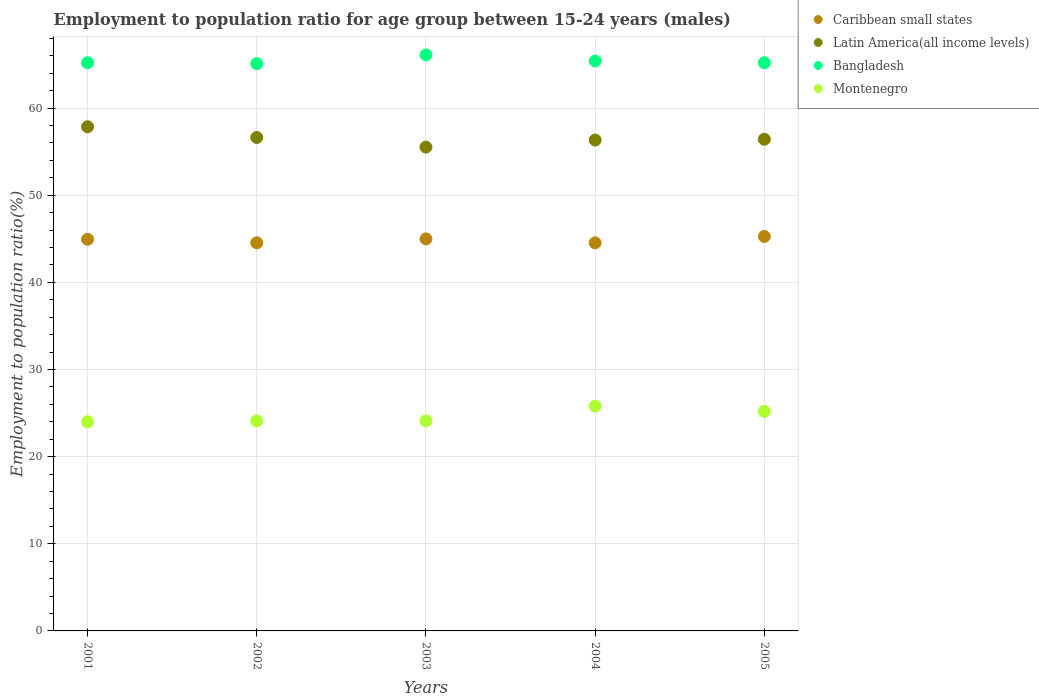What is the employment to population ratio in Bangladesh in 2001?
Offer a very short reply. 65.2. Across all years, what is the maximum employment to population ratio in Caribbean small states?
Keep it short and to the point. 45.27. Across all years, what is the minimum employment to population ratio in Latin America(all income levels)?
Your response must be concise. 55.52. In which year was the employment to population ratio in Latin America(all income levels) minimum?
Ensure brevity in your answer.  2003. What is the total employment to population ratio in Caribbean small states in the graph?
Keep it short and to the point. 224.27. What is the difference between the employment to population ratio in Montenegro in 2003 and that in 2004?
Provide a short and direct response. -1.7. What is the difference between the employment to population ratio in Montenegro in 2001 and the employment to population ratio in Caribbean small states in 2005?
Give a very brief answer. -21.27. What is the average employment to population ratio in Bangladesh per year?
Your answer should be compact. 65.4. In the year 2002, what is the difference between the employment to population ratio in Latin America(all income levels) and employment to population ratio in Bangladesh?
Offer a very short reply. -8.48. What is the ratio of the employment to population ratio in Latin America(all income levels) in 2003 to that in 2004?
Offer a very short reply. 0.99. What is the difference between the highest and the second highest employment to population ratio in Bangladesh?
Make the answer very short. 0.7. What is the difference between the highest and the lowest employment to population ratio in Caribbean small states?
Give a very brief answer. 0.73. Is the sum of the employment to population ratio in Montenegro in 2003 and 2005 greater than the maximum employment to population ratio in Bangladesh across all years?
Ensure brevity in your answer.  No. Is it the case that in every year, the sum of the employment to population ratio in Montenegro and employment to population ratio in Latin America(all income levels)  is greater than the employment to population ratio in Caribbean small states?
Your answer should be very brief. Yes. Is the employment to population ratio in Montenegro strictly greater than the employment to population ratio in Caribbean small states over the years?
Provide a succinct answer. No. Are the values on the major ticks of Y-axis written in scientific E-notation?
Offer a very short reply. No. Does the graph contain any zero values?
Offer a very short reply. No. Does the graph contain grids?
Your answer should be very brief. Yes. How are the legend labels stacked?
Give a very brief answer. Vertical. What is the title of the graph?
Offer a terse response. Employment to population ratio for age group between 15-24 years (males). Does "Aruba" appear as one of the legend labels in the graph?
Ensure brevity in your answer.  No. What is the Employment to population ratio(%) in Caribbean small states in 2001?
Make the answer very short. 44.94. What is the Employment to population ratio(%) of Latin America(all income levels) in 2001?
Provide a succinct answer. 57.85. What is the Employment to population ratio(%) of Bangladesh in 2001?
Make the answer very short. 65.2. What is the Employment to population ratio(%) of Montenegro in 2001?
Ensure brevity in your answer.  24. What is the Employment to population ratio(%) of Caribbean small states in 2002?
Give a very brief answer. 44.53. What is the Employment to population ratio(%) in Latin America(all income levels) in 2002?
Give a very brief answer. 56.62. What is the Employment to population ratio(%) of Bangladesh in 2002?
Provide a succinct answer. 65.1. What is the Employment to population ratio(%) of Montenegro in 2002?
Your answer should be compact. 24.1. What is the Employment to population ratio(%) in Caribbean small states in 2003?
Make the answer very short. 44.99. What is the Employment to population ratio(%) of Latin America(all income levels) in 2003?
Offer a terse response. 55.52. What is the Employment to population ratio(%) of Bangladesh in 2003?
Provide a short and direct response. 66.1. What is the Employment to population ratio(%) of Montenegro in 2003?
Make the answer very short. 24.1. What is the Employment to population ratio(%) in Caribbean small states in 2004?
Offer a very short reply. 44.54. What is the Employment to population ratio(%) of Latin America(all income levels) in 2004?
Your answer should be very brief. 56.33. What is the Employment to population ratio(%) of Bangladesh in 2004?
Your response must be concise. 65.4. What is the Employment to population ratio(%) in Montenegro in 2004?
Give a very brief answer. 25.8. What is the Employment to population ratio(%) of Caribbean small states in 2005?
Your answer should be very brief. 45.27. What is the Employment to population ratio(%) in Latin America(all income levels) in 2005?
Your answer should be compact. 56.42. What is the Employment to population ratio(%) of Bangladesh in 2005?
Your answer should be compact. 65.2. What is the Employment to population ratio(%) in Montenegro in 2005?
Your answer should be compact. 25.2. Across all years, what is the maximum Employment to population ratio(%) in Caribbean small states?
Ensure brevity in your answer.  45.27. Across all years, what is the maximum Employment to population ratio(%) in Latin America(all income levels)?
Your answer should be very brief. 57.85. Across all years, what is the maximum Employment to population ratio(%) of Bangladesh?
Give a very brief answer. 66.1. Across all years, what is the maximum Employment to population ratio(%) of Montenegro?
Your answer should be very brief. 25.8. Across all years, what is the minimum Employment to population ratio(%) of Caribbean small states?
Your answer should be compact. 44.53. Across all years, what is the minimum Employment to population ratio(%) of Latin America(all income levels)?
Your answer should be compact. 55.52. Across all years, what is the minimum Employment to population ratio(%) of Bangladesh?
Your answer should be very brief. 65.1. What is the total Employment to population ratio(%) in Caribbean small states in the graph?
Ensure brevity in your answer.  224.27. What is the total Employment to population ratio(%) of Latin America(all income levels) in the graph?
Keep it short and to the point. 282.75. What is the total Employment to population ratio(%) in Bangladesh in the graph?
Ensure brevity in your answer.  327. What is the total Employment to population ratio(%) in Montenegro in the graph?
Make the answer very short. 123.2. What is the difference between the Employment to population ratio(%) of Caribbean small states in 2001 and that in 2002?
Your response must be concise. 0.41. What is the difference between the Employment to population ratio(%) of Latin America(all income levels) in 2001 and that in 2002?
Make the answer very short. 1.23. What is the difference between the Employment to population ratio(%) of Caribbean small states in 2001 and that in 2003?
Offer a very short reply. -0.05. What is the difference between the Employment to population ratio(%) of Latin America(all income levels) in 2001 and that in 2003?
Offer a terse response. 2.33. What is the difference between the Employment to population ratio(%) of Montenegro in 2001 and that in 2003?
Give a very brief answer. -0.1. What is the difference between the Employment to population ratio(%) in Caribbean small states in 2001 and that in 2004?
Offer a very short reply. 0.41. What is the difference between the Employment to population ratio(%) in Latin America(all income levels) in 2001 and that in 2004?
Your response must be concise. 1.52. What is the difference between the Employment to population ratio(%) of Bangladesh in 2001 and that in 2004?
Give a very brief answer. -0.2. What is the difference between the Employment to population ratio(%) in Montenegro in 2001 and that in 2004?
Ensure brevity in your answer.  -1.8. What is the difference between the Employment to population ratio(%) of Caribbean small states in 2001 and that in 2005?
Provide a succinct answer. -0.32. What is the difference between the Employment to population ratio(%) in Latin America(all income levels) in 2001 and that in 2005?
Keep it short and to the point. 1.43. What is the difference between the Employment to population ratio(%) in Montenegro in 2001 and that in 2005?
Provide a short and direct response. -1.2. What is the difference between the Employment to population ratio(%) of Caribbean small states in 2002 and that in 2003?
Give a very brief answer. -0.46. What is the difference between the Employment to population ratio(%) in Latin America(all income levels) in 2002 and that in 2003?
Your answer should be very brief. 1.1. What is the difference between the Employment to population ratio(%) of Bangladesh in 2002 and that in 2003?
Offer a very short reply. -1. What is the difference between the Employment to population ratio(%) of Montenegro in 2002 and that in 2003?
Provide a short and direct response. 0. What is the difference between the Employment to population ratio(%) in Caribbean small states in 2002 and that in 2004?
Your answer should be compact. -0. What is the difference between the Employment to population ratio(%) in Latin America(all income levels) in 2002 and that in 2004?
Your response must be concise. 0.29. What is the difference between the Employment to population ratio(%) of Caribbean small states in 2002 and that in 2005?
Give a very brief answer. -0.73. What is the difference between the Employment to population ratio(%) in Latin America(all income levels) in 2002 and that in 2005?
Give a very brief answer. 0.2. What is the difference between the Employment to population ratio(%) in Caribbean small states in 2003 and that in 2004?
Offer a very short reply. 0.45. What is the difference between the Employment to population ratio(%) in Latin America(all income levels) in 2003 and that in 2004?
Give a very brief answer. -0.81. What is the difference between the Employment to population ratio(%) of Bangladesh in 2003 and that in 2004?
Your response must be concise. 0.7. What is the difference between the Employment to population ratio(%) in Caribbean small states in 2003 and that in 2005?
Your response must be concise. -0.28. What is the difference between the Employment to population ratio(%) of Latin America(all income levels) in 2003 and that in 2005?
Keep it short and to the point. -0.9. What is the difference between the Employment to population ratio(%) of Montenegro in 2003 and that in 2005?
Provide a short and direct response. -1.1. What is the difference between the Employment to population ratio(%) in Caribbean small states in 2004 and that in 2005?
Provide a succinct answer. -0.73. What is the difference between the Employment to population ratio(%) of Latin America(all income levels) in 2004 and that in 2005?
Your answer should be very brief. -0.09. What is the difference between the Employment to population ratio(%) of Caribbean small states in 2001 and the Employment to population ratio(%) of Latin America(all income levels) in 2002?
Your response must be concise. -11.68. What is the difference between the Employment to population ratio(%) of Caribbean small states in 2001 and the Employment to population ratio(%) of Bangladesh in 2002?
Ensure brevity in your answer.  -20.16. What is the difference between the Employment to population ratio(%) of Caribbean small states in 2001 and the Employment to population ratio(%) of Montenegro in 2002?
Offer a very short reply. 20.84. What is the difference between the Employment to population ratio(%) of Latin America(all income levels) in 2001 and the Employment to population ratio(%) of Bangladesh in 2002?
Your answer should be very brief. -7.25. What is the difference between the Employment to population ratio(%) in Latin America(all income levels) in 2001 and the Employment to population ratio(%) in Montenegro in 2002?
Provide a short and direct response. 33.75. What is the difference between the Employment to population ratio(%) in Bangladesh in 2001 and the Employment to population ratio(%) in Montenegro in 2002?
Give a very brief answer. 41.1. What is the difference between the Employment to population ratio(%) of Caribbean small states in 2001 and the Employment to population ratio(%) of Latin America(all income levels) in 2003?
Ensure brevity in your answer.  -10.58. What is the difference between the Employment to population ratio(%) in Caribbean small states in 2001 and the Employment to population ratio(%) in Bangladesh in 2003?
Give a very brief answer. -21.16. What is the difference between the Employment to population ratio(%) in Caribbean small states in 2001 and the Employment to population ratio(%) in Montenegro in 2003?
Make the answer very short. 20.84. What is the difference between the Employment to population ratio(%) of Latin America(all income levels) in 2001 and the Employment to population ratio(%) of Bangladesh in 2003?
Your answer should be very brief. -8.25. What is the difference between the Employment to population ratio(%) in Latin America(all income levels) in 2001 and the Employment to population ratio(%) in Montenegro in 2003?
Ensure brevity in your answer.  33.75. What is the difference between the Employment to population ratio(%) in Bangladesh in 2001 and the Employment to population ratio(%) in Montenegro in 2003?
Offer a very short reply. 41.1. What is the difference between the Employment to population ratio(%) in Caribbean small states in 2001 and the Employment to population ratio(%) in Latin America(all income levels) in 2004?
Keep it short and to the point. -11.39. What is the difference between the Employment to population ratio(%) of Caribbean small states in 2001 and the Employment to population ratio(%) of Bangladesh in 2004?
Make the answer very short. -20.46. What is the difference between the Employment to population ratio(%) in Caribbean small states in 2001 and the Employment to population ratio(%) in Montenegro in 2004?
Offer a very short reply. 19.14. What is the difference between the Employment to population ratio(%) of Latin America(all income levels) in 2001 and the Employment to population ratio(%) of Bangladesh in 2004?
Your answer should be very brief. -7.55. What is the difference between the Employment to population ratio(%) in Latin America(all income levels) in 2001 and the Employment to population ratio(%) in Montenegro in 2004?
Provide a short and direct response. 32.05. What is the difference between the Employment to population ratio(%) in Bangladesh in 2001 and the Employment to population ratio(%) in Montenegro in 2004?
Provide a short and direct response. 39.4. What is the difference between the Employment to population ratio(%) of Caribbean small states in 2001 and the Employment to population ratio(%) of Latin America(all income levels) in 2005?
Your answer should be compact. -11.48. What is the difference between the Employment to population ratio(%) in Caribbean small states in 2001 and the Employment to population ratio(%) in Bangladesh in 2005?
Provide a succinct answer. -20.26. What is the difference between the Employment to population ratio(%) in Caribbean small states in 2001 and the Employment to population ratio(%) in Montenegro in 2005?
Your answer should be very brief. 19.74. What is the difference between the Employment to population ratio(%) of Latin America(all income levels) in 2001 and the Employment to population ratio(%) of Bangladesh in 2005?
Keep it short and to the point. -7.35. What is the difference between the Employment to population ratio(%) of Latin America(all income levels) in 2001 and the Employment to population ratio(%) of Montenegro in 2005?
Give a very brief answer. 32.65. What is the difference between the Employment to population ratio(%) of Bangladesh in 2001 and the Employment to population ratio(%) of Montenegro in 2005?
Ensure brevity in your answer.  40. What is the difference between the Employment to population ratio(%) of Caribbean small states in 2002 and the Employment to population ratio(%) of Latin America(all income levels) in 2003?
Give a very brief answer. -10.99. What is the difference between the Employment to population ratio(%) of Caribbean small states in 2002 and the Employment to population ratio(%) of Bangladesh in 2003?
Provide a succinct answer. -21.57. What is the difference between the Employment to population ratio(%) in Caribbean small states in 2002 and the Employment to population ratio(%) in Montenegro in 2003?
Your answer should be very brief. 20.43. What is the difference between the Employment to population ratio(%) in Latin America(all income levels) in 2002 and the Employment to population ratio(%) in Bangladesh in 2003?
Make the answer very short. -9.48. What is the difference between the Employment to population ratio(%) of Latin America(all income levels) in 2002 and the Employment to population ratio(%) of Montenegro in 2003?
Make the answer very short. 32.52. What is the difference between the Employment to population ratio(%) of Bangladesh in 2002 and the Employment to population ratio(%) of Montenegro in 2003?
Offer a very short reply. 41. What is the difference between the Employment to population ratio(%) of Caribbean small states in 2002 and the Employment to population ratio(%) of Latin America(all income levels) in 2004?
Offer a terse response. -11.8. What is the difference between the Employment to population ratio(%) of Caribbean small states in 2002 and the Employment to population ratio(%) of Bangladesh in 2004?
Keep it short and to the point. -20.87. What is the difference between the Employment to population ratio(%) of Caribbean small states in 2002 and the Employment to population ratio(%) of Montenegro in 2004?
Your answer should be compact. 18.73. What is the difference between the Employment to population ratio(%) in Latin America(all income levels) in 2002 and the Employment to population ratio(%) in Bangladesh in 2004?
Provide a short and direct response. -8.78. What is the difference between the Employment to population ratio(%) in Latin America(all income levels) in 2002 and the Employment to population ratio(%) in Montenegro in 2004?
Offer a terse response. 30.82. What is the difference between the Employment to population ratio(%) in Bangladesh in 2002 and the Employment to population ratio(%) in Montenegro in 2004?
Offer a very short reply. 39.3. What is the difference between the Employment to population ratio(%) in Caribbean small states in 2002 and the Employment to population ratio(%) in Latin America(all income levels) in 2005?
Offer a terse response. -11.89. What is the difference between the Employment to population ratio(%) in Caribbean small states in 2002 and the Employment to population ratio(%) in Bangladesh in 2005?
Offer a very short reply. -20.67. What is the difference between the Employment to population ratio(%) in Caribbean small states in 2002 and the Employment to population ratio(%) in Montenegro in 2005?
Offer a terse response. 19.33. What is the difference between the Employment to population ratio(%) of Latin America(all income levels) in 2002 and the Employment to population ratio(%) of Bangladesh in 2005?
Your response must be concise. -8.58. What is the difference between the Employment to population ratio(%) of Latin America(all income levels) in 2002 and the Employment to population ratio(%) of Montenegro in 2005?
Provide a succinct answer. 31.42. What is the difference between the Employment to population ratio(%) in Bangladesh in 2002 and the Employment to population ratio(%) in Montenegro in 2005?
Give a very brief answer. 39.9. What is the difference between the Employment to population ratio(%) in Caribbean small states in 2003 and the Employment to population ratio(%) in Latin America(all income levels) in 2004?
Provide a short and direct response. -11.34. What is the difference between the Employment to population ratio(%) of Caribbean small states in 2003 and the Employment to population ratio(%) of Bangladesh in 2004?
Provide a short and direct response. -20.41. What is the difference between the Employment to population ratio(%) in Caribbean small states in 2003 and the Employment to population ratio(%) in Montenegro in 2004?
Ensure brevity in your answer.  19.19. What is the difference between the Employment to population ratio(%) in Latin America(all income levels) in 2003 and the Employment to population ratio(%) in Bangladesh in 2004?
Keep it short and to the point. -9.88. What is the difference between the Employment to population ratio(%) of Latin America(all income levels) in 2003 and the Employment to population ratio(%) of Montenegro in 2004?
Your response must be concise. 29.72. What is the difference between the Employment to population ratio(%) in Bangladesh in 2003 and the Employment to population ratio(%) in Montenegro in 2004?
Provide a short and direct response. 40.3. What is the difference between the Employment to population ratio(%) of Caribbean small states in 2003 and the Employment to population ratio(%) of Latin America(all income levels) in 2005?
Provide a short and direct response. -11.43. What is the difference between the Employment to population ratio(%) in Caribbean small states in 2003 and the Employment to population ratio(%) in Bangladesh in 2005?
Give a very brief answer. -20.21. What is the difference between the Employment to population ratio(%) of Caribbean small states in 2003 and the Employment to population ratio(%) of Montenegro in 2005?
Offer a very short reply. 19.79. What is the difference between the Employment to population ratio(%) in Latin America(all income levels) in 2003 and the Employment to population ratio(%) in Bangladesh in 2005?
Your answer should be very brief. -9.68. What is the difference between the Employment to population ratio(%) in Latin America(all income levels) in 2003 and the Employment to population ratio(%) in Montenegro in 2005?
Your answer should be very brief. 30.32. What is the difference between the Employment to population ratio(%) in Bangladesh in 2003 and the Employment to population ratio(%) in Montenegro in 2005?
Offer a terse response. 40.9. What is the difference between the Employment to population ratio(%) of Caribbean small states in 2004 and the Employment to population ratio(%) of Latin America(all income levels) in 2005?
Ensure brevity in your answer.  -11.89. What is the difference between the Employment to population ratio(%) of Caribbean small states in 2004 and the Employment to population ratio(%) of Bangladesh in 2005?
Ensure brevity in your answer.  -20.66. What is the difference between the Employment to population ratio(%) in Caribbean small states in 2004 and the Employment to population ratio(%) in Montenegro in 2005?
Your answer should be compact. 19.34. What is the difference between the Employment to population ratio(%) in Latin America(all income levels) in 2004 and the Employment to population ratio(%) in Bangladesh in 2005?
Provide a succinct answer. -8.87. What is the difference between the Employment to population ratio(%) in Latin America(all income levels) in 2004 and the Employment to population ratio(%) in Montenegro in 2005?
Make the answer very short. 31.13. What is the difference between the Employment to population ratio(%) in Bangladesh in 2004 and the Employment to population ratio(%) in Montenegro in 2005?
Provide a short and direct response. 40.2. What is the average Employment to population ratio(%) of Caribbean small states per year?
Make the answer very short. 44.85. What is the average Employment to population ratio(%) of Latin America(all income levels) per year?
Make the answer very short. 56.55. What is the average Employment to population ratio(%) in Bangladesh per year?
Your answer should be very brief. 65.4. What is the average Employment to population ratio(%) of Montenegro per year?
Give a very brief answer. 24.64. In the year 2001, what is the difference between the Employment to population ratio(%) in Caribbean small states and Employment to population ratio(%) in Latin America(all income levels)?
Ensure brevity in your answer.  -12.91. In the year 2001, what is the difference between the Employment to population ratio(%) in Caribbean small states and Employment to population ratio(%) in Bangladesh?
Your response must be concise. -20.26. In the year 2001, what is the difference between the Employment to population ratio(%) in Caribbean small states and Employment to population ratio(%) in Montenegro?
Your answer should be compact. 20.94. In the year 2001, what is the difference between the Employment to population ratio(%) in Latin America(all income levels) and Employment to population ratio(%) in Bangladesh?
Give a very brief answer. -7.35. In the year 2001, what is the difference between the Employment to population ratio(%) of Latin America(all income levels) and Employment to population ratio(%) of Montenegro?
Make the answer very short. 33.85. In the year 2001, what is the difference between the Employment to population ratio(%) in Bangladesh and Employment to population ratio(%) in Montenegro?
Your response must be concise. 41.2. In the year 2002, what is the difference between the Employment to population ratio(%) of Caribbean small states and Employment to population ratio(%) of Latin America(all income levels)?
Give a very brief answer. -12.09. In the year 2002, what is the difference between the Employment to population ratio(%) in Caribbean small states and Employment to population ratio(%) in Bangladesh?
Your response must be concise. -20.57. In the year 2002, what is the difference between the Employment to population ratio(%) of Caribbean small states and Employment to population ratio(%) of Montenegro?
Provide a succinct answer. 20.43. In the year 2002, what is the difference between the Employment to population ratio(%) of Latin America(all income levels) and Employment to population ratio(%) of Bangladesh?
Keep it short and to the point. -8.48. In the year 2002, what is the difference between the Employment to population ratio(%) of Latin America(all income levels) and Employment to population ratio(%) of Montenegro?
Ensure brevity in your answer.  32.52. In the year 2003, what is the difference between the Employment to population ratio(%) of Caribbean small states and Employment to population ratio(%) of Latin America(all income levels)?
Your response must be concise. -10.53. In the year 2003, what is the difference between the Employment to population ratio(%) in Caribbean small states and Employment to population ratio(%) in Bangladesh?
Offer a terse response. -21.11. In the year 2003, what is the difference between the Employment to population ratio(%) in Caribbean small states and Employment to population ratio(%) in Montenegro?
Offer a very short reply. 20.89. In the year 2003, what is the difference between the Employment to population ratio(%) of Latin America(all income levels) and Employment to population ratio(%) of Bangladesh?
Your answer should be compact. -10.58. In the year 2003, what is the difference between the Employment to population ratio(%) in Latin America(all income levels) and Employment to population ratio(%) in Montenegro?
Give a very brief answer. 31.42. In the year 2004, what is the difference between the Employment to population ratio(%) in Caribbean small states and Employment to population ratio(%) in Latin America(all income levels)?
Your response must be concise. -11.8. In the year 2004, what is the difference between the Employment to population ratio(%) of Caribbean small states and Employment to population ratio(%) of Bangladesh?
Give a very brief answer. -20.86. In the year 2004, what is the difference between the Employment to population ratio(%) of Caribbean small states and Employment to population ratio(%) of Montenegro?
Your answer should be very brief. 18.74. In the year 2004, what is the difference between the Employment to population ratio(%) of Latin America(all income levels) and Employment to population ratio(%) of Bangladesh?
Your response must be concise. -9.07. In the year 2004, what is the difference between the Employment to population ratio(%) of Latin America(all income levels) and Employment to population ratio(%) of Montenegro?
Offer a very short reply. 30.53. In the year 2004, what is the difference between the Employment to population ratio(%) in Bangladesh and Employment to population ratio(%) in Montenegro?
Offer a very short reply. 39.6. In the year 2005, what is the difference between the Employment to population ratio(%) of Caribbean small states and Employment to population ratio(%) of Latin America(all income levels)?
Your answer should be compact. -11.15. In the year 2005, what is the difference between the Employment to population ratio(%) in Caribbean small states and Employment to population ratio(%) in Bangladesh?
Keep it short and to the point. -19.93. In the year 2005, what is the difference between the Employment to population ratio(%) in Caribbean small states and Employment to population ratio(%) in Montenegro?
Offer a terse response. 20.07. In the year 2005, what is the difference between the Employment to population ratio(%) in Latin America(all income levels) and Employment to population ratio(%) in Bangladesh?
Provide a short and direct response. -8.78. In the year 2005, what is the difference between the Employment to population ratio(%) in Latin America(all income levels) and Employment to population ratio(%) in Montenegro?
Keep it short and to the point. 31.22. What is the ratio of the Employment to population ratio(%) of Caribbean small states in 2001 to that in 2002?
Keep it short and to the point. 1.01. What is the ratio of the Employment to population ratio(%) of Latin America(all income levels) in 2001 to that in 2002?
Offer a very short reply. 1.02. What is the ratio of the Employment to population ratio(%) of Caribbean small states in 2001 to that in 2003?
Your response must be concise. 1. What is the ratio of the Employment to population ratio(%) in Latin America(all income levels) in 2001 to that in 2003?
Ensure brevity in your answer.  1.04. What is the ratio of the Employment to population ratio(%) in Bangladesh in 2001 to that in 2003?
Your answer should be compact. 0.99. What is the ratio of the Employment to population ratio(%) in Montenegro in 2001 to that in 2003?
Your response must be concise. 1. What is the ratio of the Employment to population ratio(%) of Caribbean small states in 2001 to that in 2004?
Your answer should be very brief. 1.01. What is the ratio of the Employment to population ratio(%) of Latin America(all income levels) in 2001 to that in 2004?
Offer a very short reply. 1.03. What is the ratio of the Employment to population ratio(%) in Bangladesh in 2001 to that in 2004?
Give a very brief answer. 1. What is the ratio of the Employment to population ratio(%) of Montenegro in 2001 to that in 2004?
Ensure brevity in your answer.  0.93. What is the ratio of the Employment to population ratio(%) in Caribbean small states in 2001 to that in 2005?
Make the answer very short. 0.99. What is the ratio of the Employment to population ratio(%) of Latin America(all income levels) in 2001 to that in 2005?
Offer a very short reply. 1.03. What is the ratio of the Employment to population ratio(%) of Montenegro in 2001 to that in 2005?
Your answer should be compact. 0.95. What is the ratio of the Employment to population ratio(%) of Latin America(all income levels) in 2002 to that in 2003?
Your response must be concise. 1.02. What is the ratio of the Employment to population ratio(%) in Bangladesh in 2002 to that in 2003?
Offer a very short reply. 0.98. What is the ratio of the Employment to population ratio(%) in Caribbean small states in 2002 to that in 2004?
Your answer should be compact. 1. What is the ratio of the Employment to population ratio(%) in Latin America(all income levels) in 2002 to that in 2004?
Your answer should be compact. 1.01. What is the ratio of the Employment to population ratio(%) in Bangladesh in 2002 to that in 2004?
Your response must be concise. 1. What is the ratio of the Employment to population ratio(%) of Montenegro in 2002 to that in 2004?
Give a very brief answer. 0.93. What is the ratio of the Employment to population ratio(%) in Caribbean small states in 2002 to that in 2005?
Make the answer very short. 0.98. What is the ratio of the Employment to population ratio(%) in Montenegro in 2002 to that in 2005?
Ensure brevity in your answer.  0.96. What is the ratio of the Employment to population ratio(%) in Caribbean small states in 2003 to that in 2004?
Your response must be concise. 1.01. What is the ratio of the Employment to population ratio(%) of Latin America(all income levels) in 2003 to that in 2004?
Provide a short and direct response. 0.99. What is the ratio of the Employment to population ratio(%) of Bangladesh in 2003 to that in 2004?
Give a very brief answer. 1.01. What is the ratio of the Employment to population ratio(%) of Montenegro in 2003 to that in 2004?
Make the answer very short. 0.93. What is the ratio of the Employment to population ratio(%) in Caribbean small states in 2003 to that in 2005?
Your response must be concise. 0.99. What is the ratio of the Employment to population ratio(%) in Latin America(all income levels) in 2003 to that in 2005?
Ensure brevity in your answer.  0.98. What is the ratio of the Employment to population ratio(%) in Bangladesh in 2003 to that in 2005?
Your response must be concise. 1.01. What is the ratio of the Employment to population ratio(%) in Montenegro in 2003 to that in 2005?
Ensure brevity in your answer.  0.96. What is the ratio of the Employment to population ratio(%) in Caribbean small states in 2004 to that in 2005?
Your answer should be compact. 0.98. What is the ratio of the Employment to population ratio(%) in Latin America(all income levels) in 2004 to that in 2005?
Your response must be concise. 1. What is the ratio of the Employment to population ratio(%) in Bangladesh in 2004 to that in 2005?
Give a very brief answer. 1. What is the ratio of the Employment to population ratio(%) in Montenegro in 2004 to that in 2005?
Ensure brevity in your answer.  1.02. What is the difference between the highest and the second highest Employment to population ratio(%) of Caribbean small states?
Provide a short and direct response. 0.28. What is the difference between the highest and the second highest Employment to population ratio(%) of Latin America(all income levels)?
Provide a succinct answer. 1.23. What is the difference between the highest and the lowest Employment to population ratio(%) in Caribbean small states?
Make the answer very short. 0.73. What is the difference between the highest and the lowest Employment to population ratio(%) in Latin America(all income levels)?
Offer a terse response. 2.33. What is the difference between the highest and the lowest Employment to population ratio(%) of Bangladesh?
Keep it short and to the point. 1. 